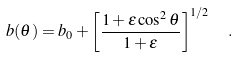<formula> <loc_0><loc_0><loc_500><loc_500>b ( \theta ) = b _ { 0 } + \left [ \frac { 1 + \epsilon \cos ^ { 2 } \theta } { 1 + \epsilon } \right ] ^ { 1 / 2 } \ \ .</formula> 